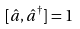Convert formula to latex. <formula><loc_0><loc_0><loc_500><loc_500>[ \hat { a } , \hat { a } ^ { \dagger } ] = 1</formula> 